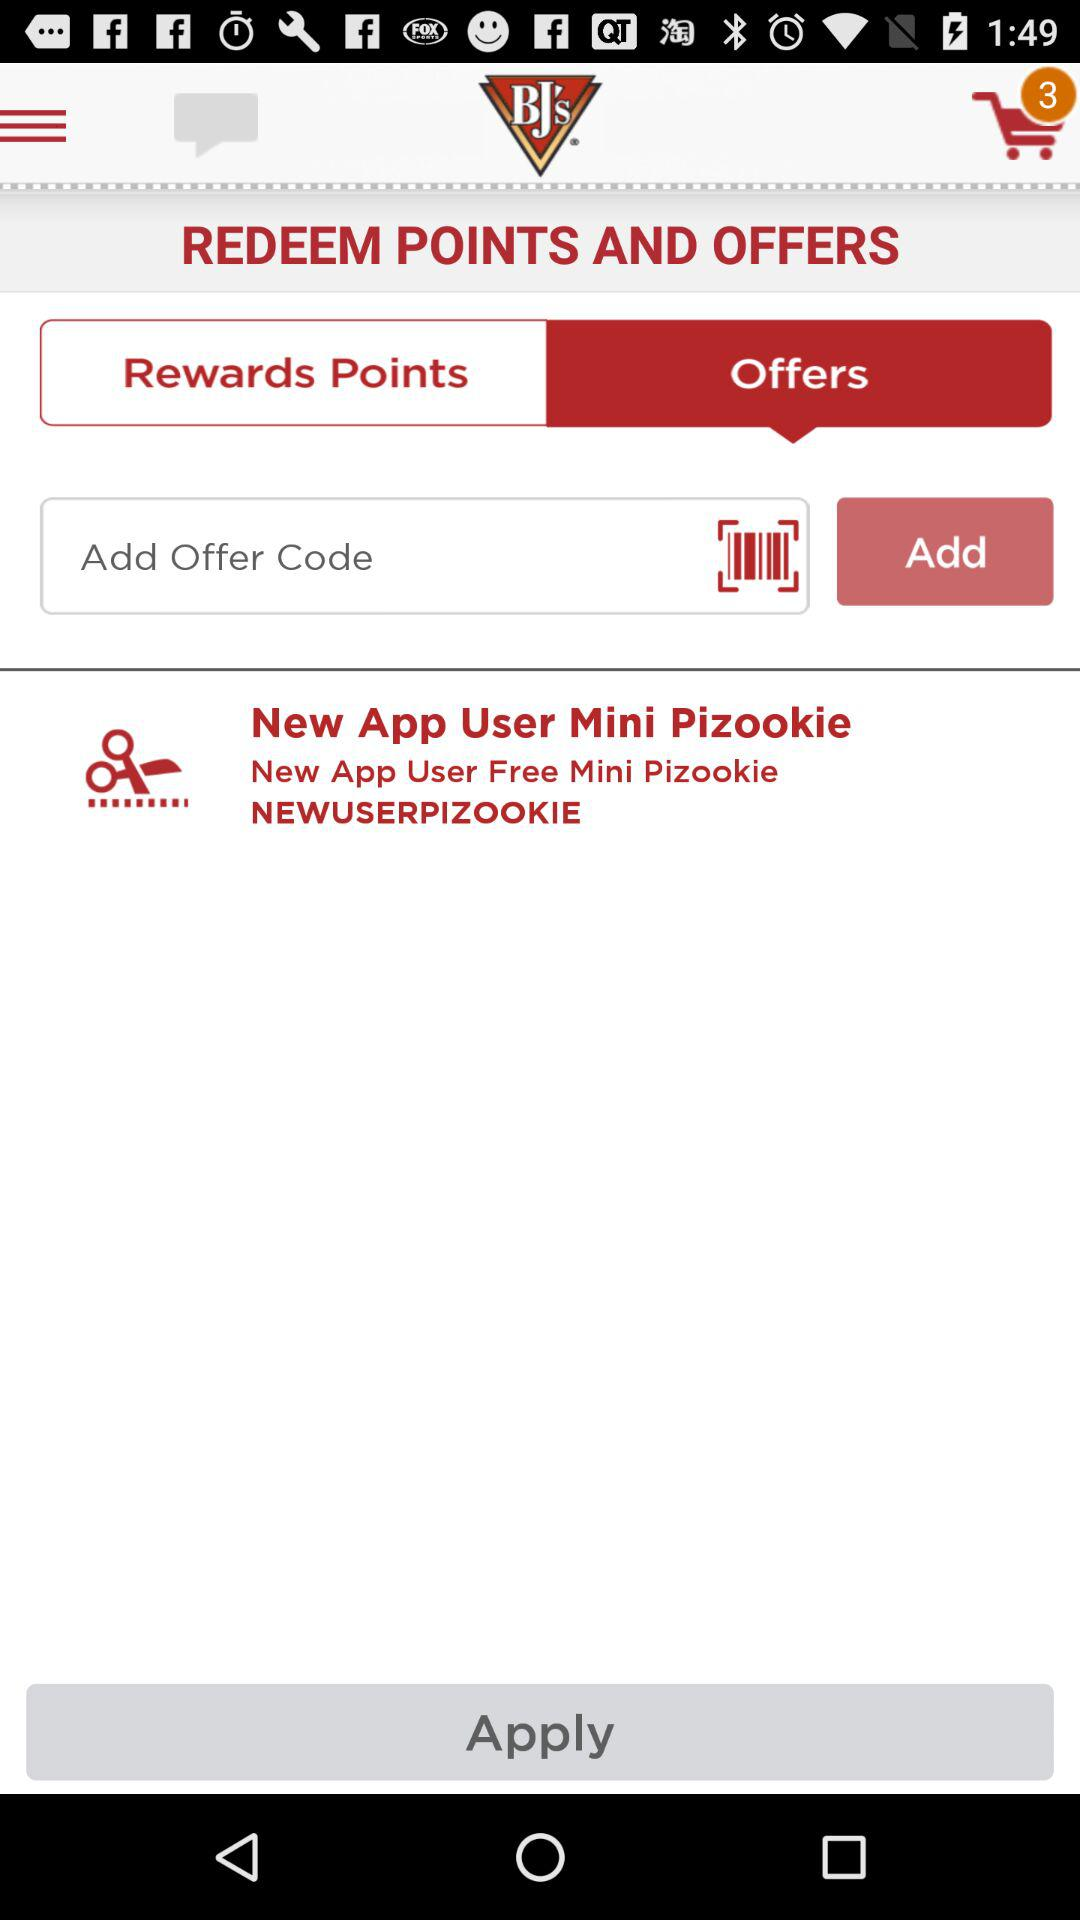How many items are there in the cart? There are 3 items in the cart. 